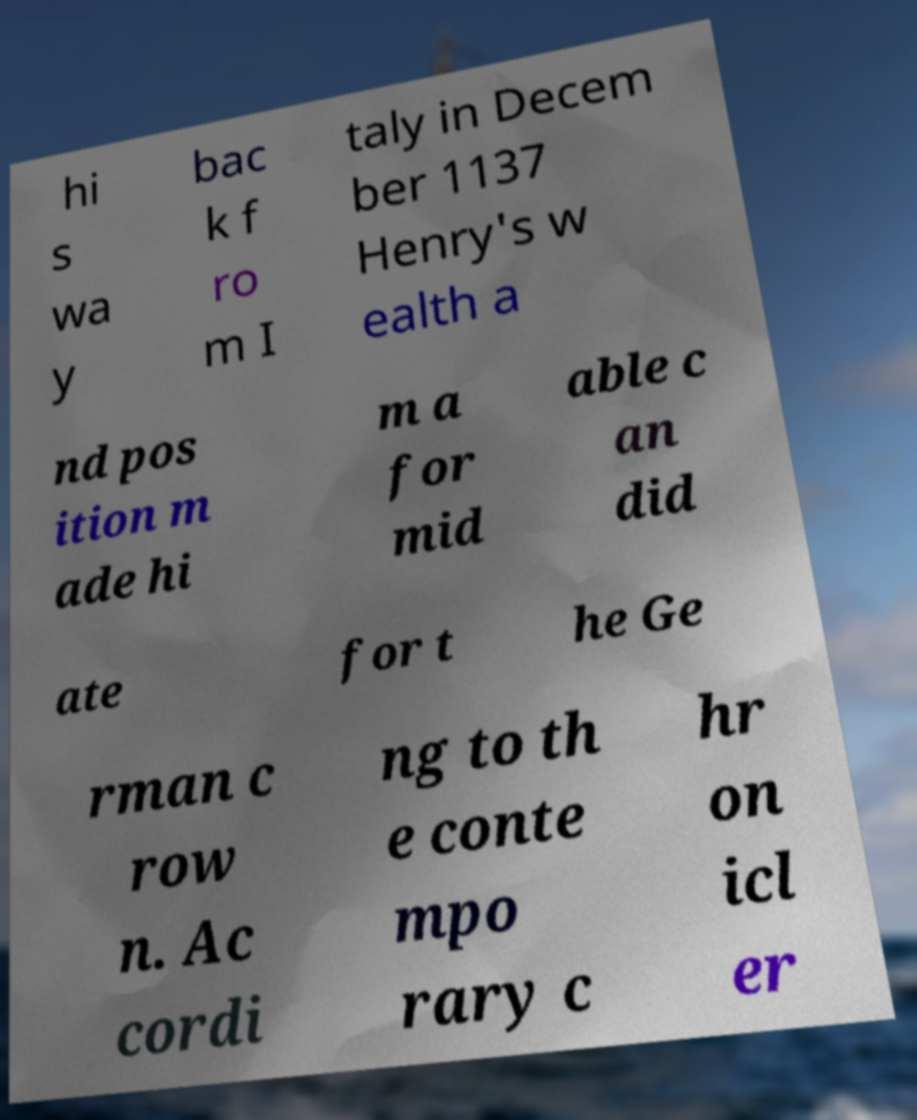Please identify and transcribe the text found in this image. hi s wa y bac k f ro m I taly in Decem ber 1137 Henry's w ealth a nd pos ition m ade hi m a for mid able c an did ate for t he Ge rman c row n. Ac cordi ng to th e conte mpo rary c hr on icl er 